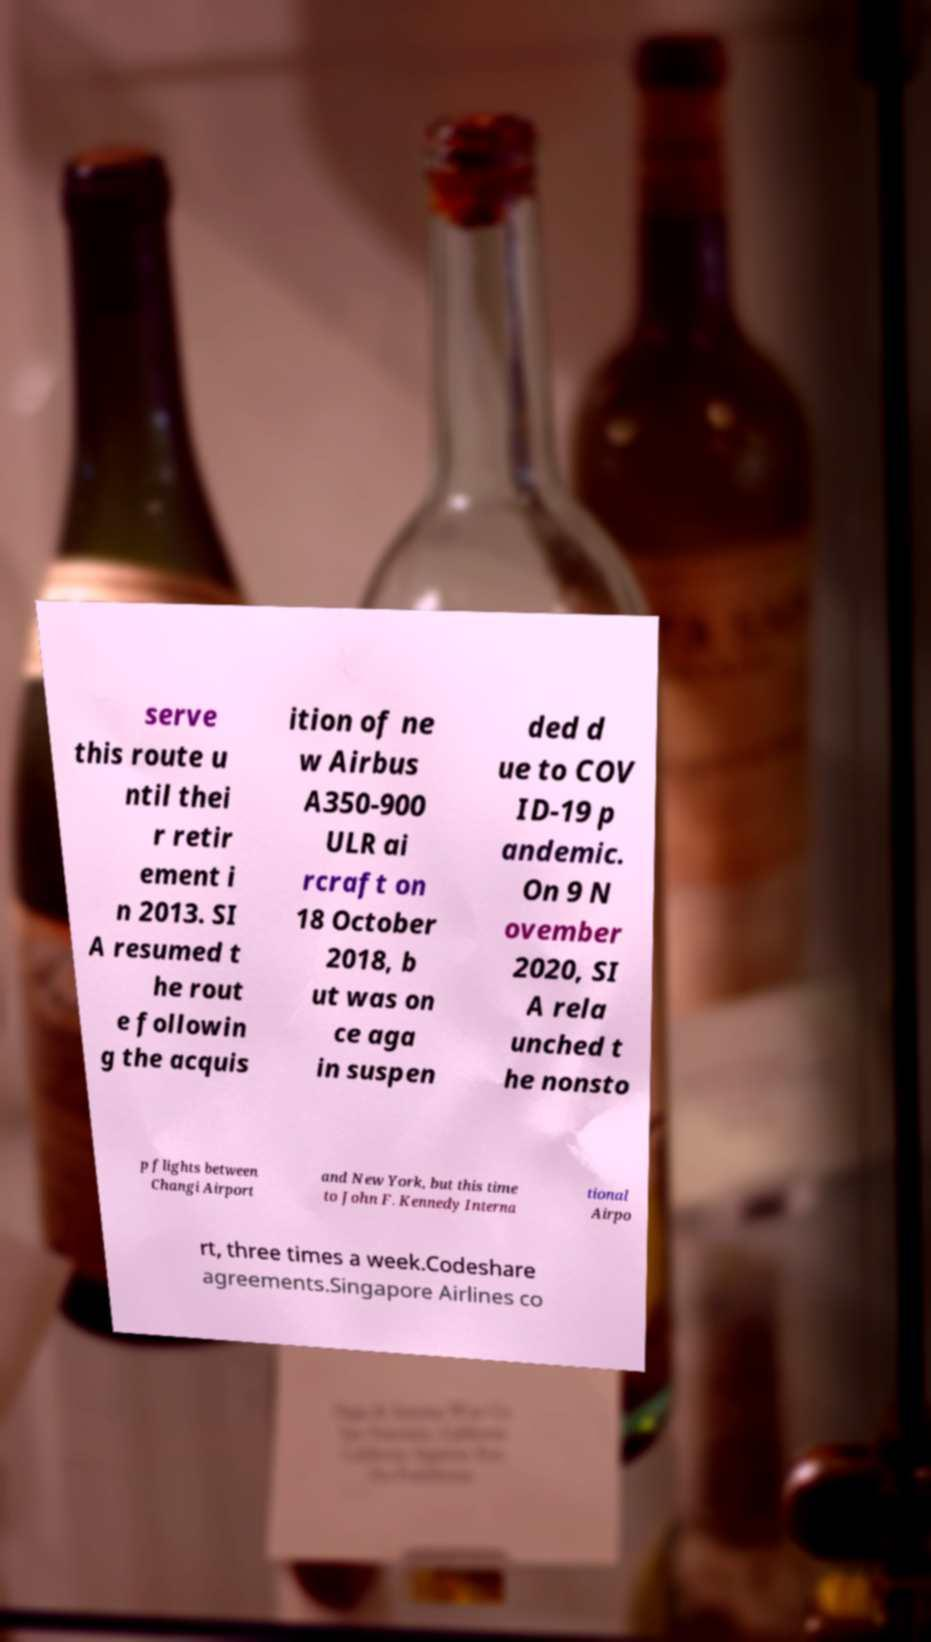Could you extract and type out the text from this image? serve this route u ntil thei r retir ement i n 2013. SI A resumed t he rout e followin g the acquis ition of ne w Airbus A350-900 ULR ai rcraft on 18 October 2018, b ut was on ce aga in suspen ded d ue to COV ID-19 p andemic. On 9 N ovember 2020, SI A rela unched t he nonsto p flights between Changi Airport and New York, but this time to John F. Kennedy Interna tional Airpo rt, three times a week.Codeshare agreements.Singapore Airlines co 